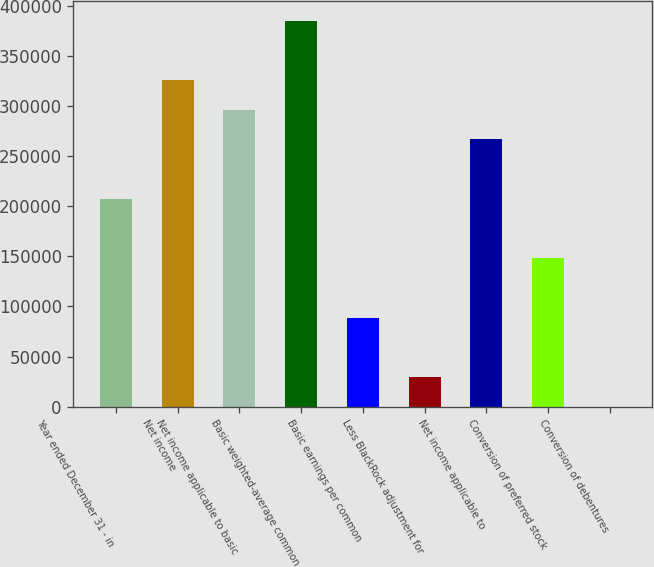Convert chart. <chart><loc_0><loc_0><loc_500><loc_500><bar_chart><fcel>Year ended December 31 - in<fcel>Net income<fcel>Net income applicable to basic<fcel>Basic weighted-average common<fcel>Basic earnings per common<fcel>Less BlackRock adjustment for<fcel>Net income applicable to<fcel>Conversion of preferred stock<fcel>Conversion of debentures<nl><fcel>207566<fcel>326174<fcel>296522<fcel>385478<fcel>88958<fcel>29654<fcel>266870<fcel>148262<fcel>2<nl></chart> 